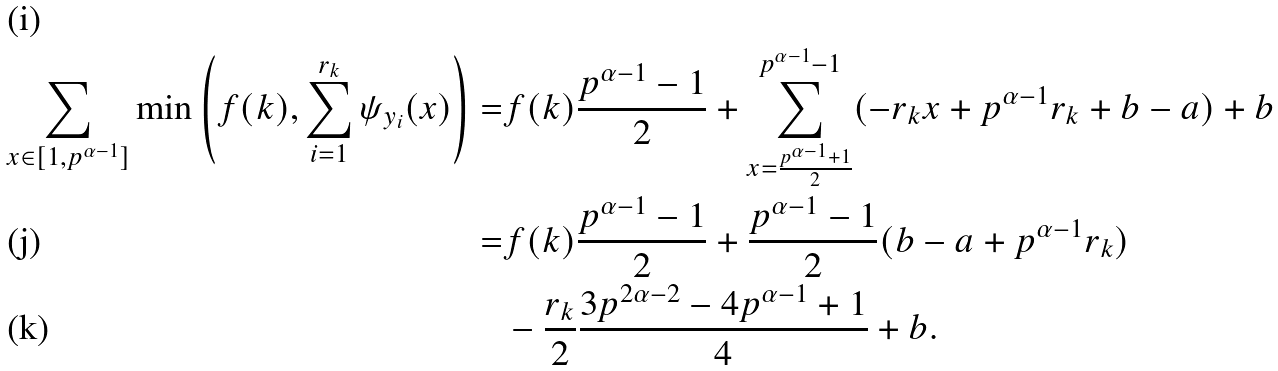Convert formula to latex. <formula><loc_0><loc_0><loc_500><loc_500>\sum _ { x \in [ 1 , p ^ { \alpha - 1 } ] } \min \left ( f ( k ) , \sum _ { i = 1 } ^ { r _ { k } } \psi _ { y _ { i } } ( x ) \right ) = & f ( k ) \frac { p ^ { \alpha - 1 } - 1 } { 2 } + \sum _ { x = \frac { p ^ { \alpha - 1 } + 1 } { 2 } } ^ { p ^ { \alpha - 1 } - 1 } ( - r _ { k } x + p ^ { \alpha - 1 } r _ { k } + b - a ) + b \\ = & f ( k ) \frac { p ^ { \alpha - 1 } - 1 } { 2 } + \frac { p ^ { \alpha - 1 } - 1 } { 2 } ( b - a + p ^ { \alpha - 1 } r _ { k } ) \\ & - \frac { r _ { k } } { 2 } \frac { 3 p ^ { 2 \alpha - 2 } - 4 p ^ { \alpha - 1 } + 1 } { 4 } + b .</formula> 